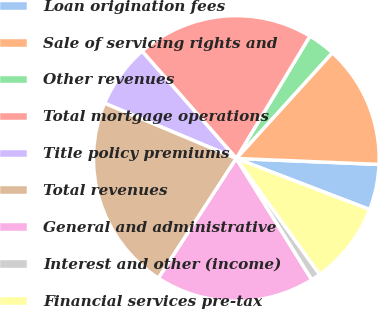<chart> <loc_0><loc_0><loc_500><loc_500><pie_chart><fcel>Loan origination fees<fcel>Sale of servicing rights and<fcel>Other revenues<fcel>Total mortgage operations<fcel>Title policy premiums<fcel>Total revenues<fcel>General and administrative<fcel>Interest and other (income)<fcel>Financial services pre-tax<nl><fcel>5.16%<fcel>13.93%<fcel>3.11%<fcel>20.09%<fcel>7.21%<fcel>22.14%<fcel>18.04%<fcel>1.06%<fcel>9.26%<nl></chart> 